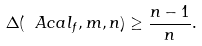Convert formula to latex. <formula><loc_0><loc_0><loc_500><loc_500>\Delta ( \ A c a l _ { f } , m , n ) \geq \frac { n - 1 } { n } .</formula> 